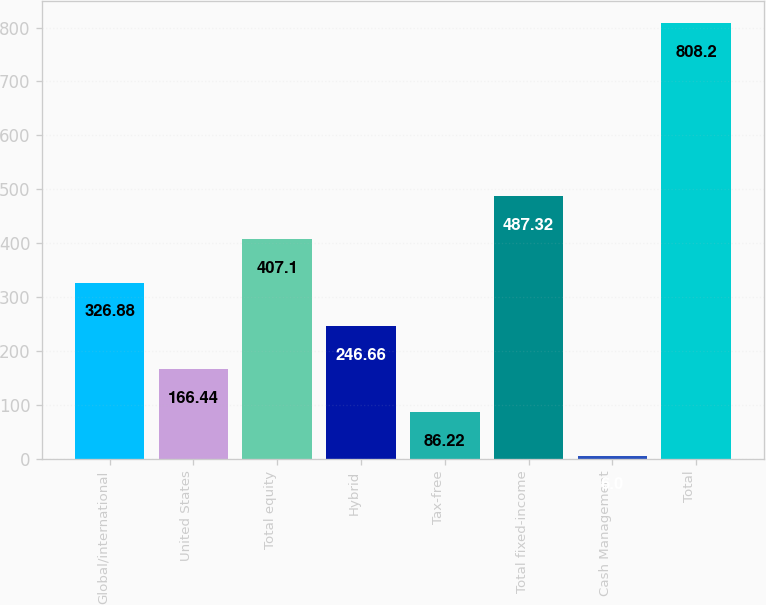<chart> <loc_0><loc_0><loc_500><loc_500><bar_chart><fcel>Global/international<fcel>United States<fcel>Total equity<fcel>Hybrid<fcel>Tax-free<fcel>Total fixed-income<fcel>Cash Management<fcel>Total<nl><fcel>326.88<fcel>166.44<fcel>407.1<fcel>246.66<fcel>86.22<fcel>487.32<fcel>6<fcel>808.2<nl></chart> 